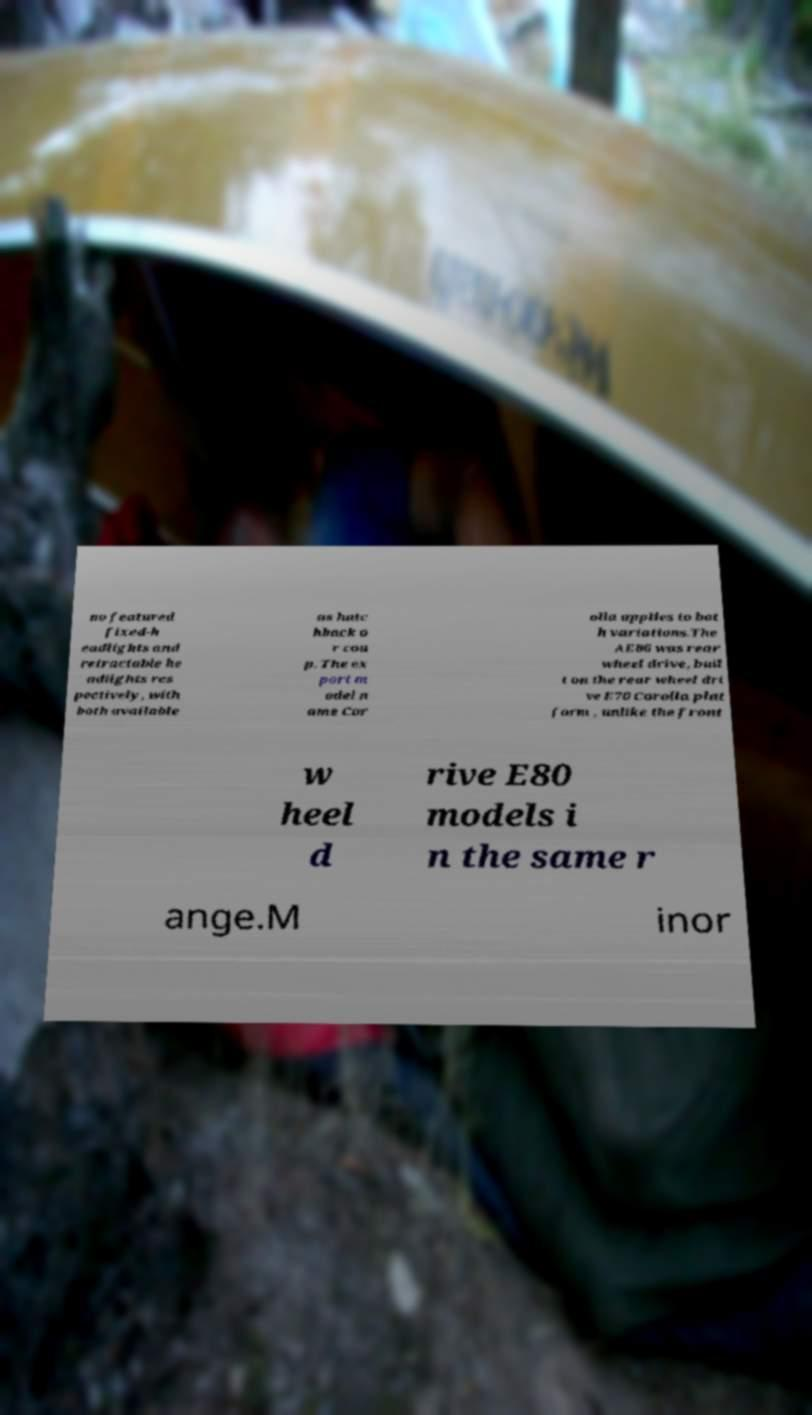There's text embedded in this image that I need extracted. Can you transcribe it verbatim? no featured fixed-h eadlights and retractable he adlights res pectively, with both available as hatc hback o r cou p. The ex port m odel n ame Cor olla applies to bot h variations.The AE86 was rear wheel drive, buil t on the rear wheel dri ve E70 Corolla plat form , unlike the front w heel d rive E80 models i n the same r ange.M inor 